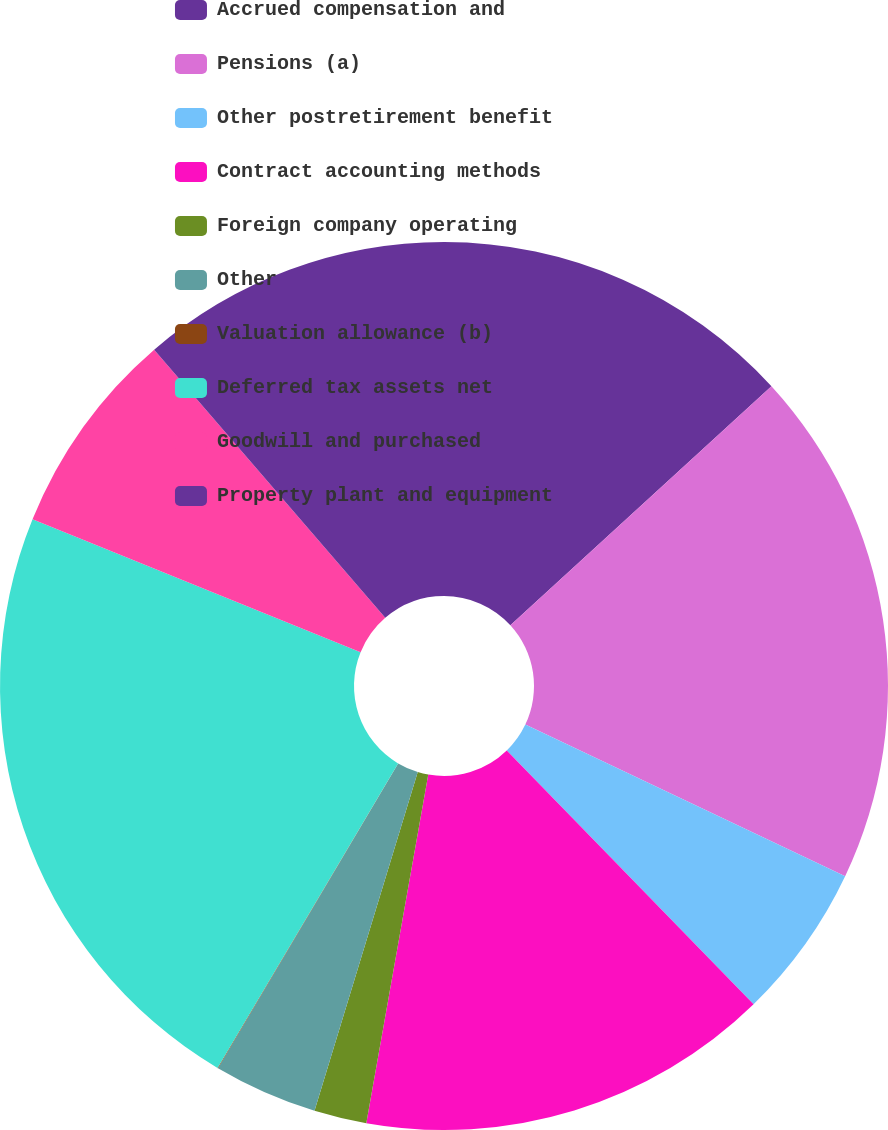Convert chart. <chart><loc_0><loc_0><loc_500><loc_500><pie_chart><fcel>Accrued compensation and<fcel>Pensions (a)<fcel>Other postretirement benefit<fcel>Contract accounting methods<fcel>Foreign company operating<fcel>Other<fcel>Valuation allowance (b)<fcel>Deferred tax assets net<fcel>Goodwill and purchased<fcel>Property plant and equipment<nl><fcel>13.2%<fcel>18.85%<fcel>5.67%<fcel>15.08%<fcel>1.91%<fcel>3.79%<fcel>0.02%<fcel>22.61%<fcel>7.55%<fcel>11.32%<nl></chart> 